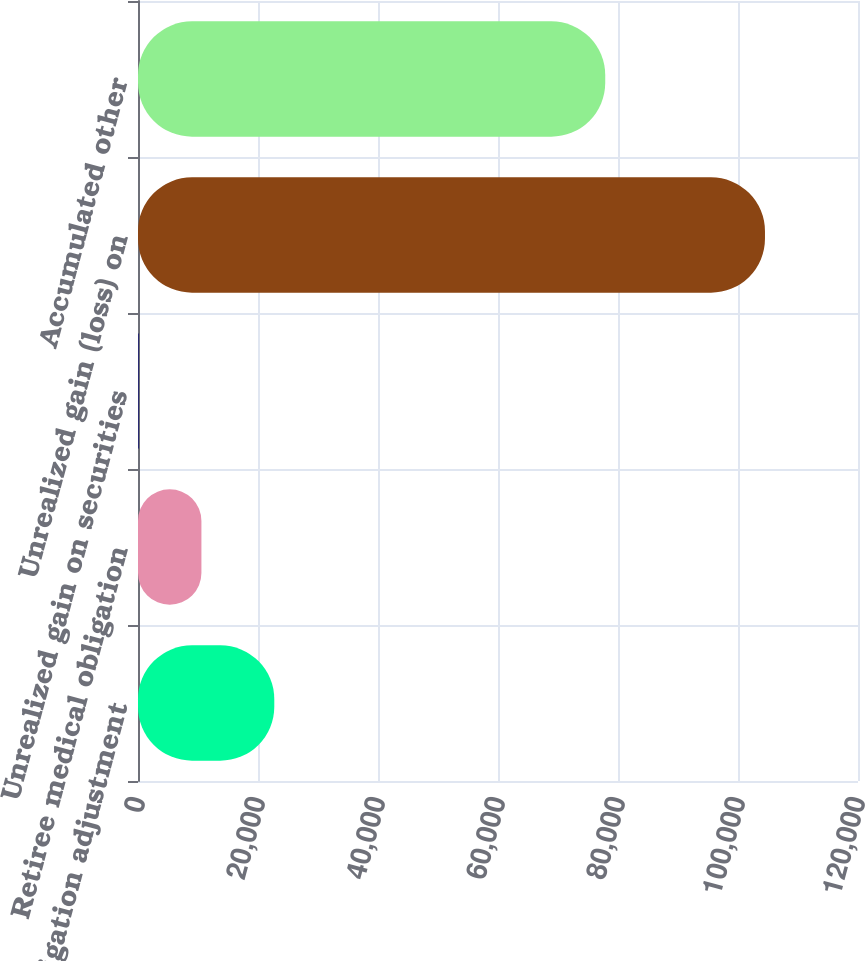Convert chart to OTSL. <chart><loc_0><loc_0><loc_500><loc_500><bar_chart><fcel>Pension obligation adjustment<fcel>Retiree medical obligation<fcel>Unrealized gain on securities<fcel>Unrealized gain (loss) on<fcel>Accumulated other<nl><fcel>22715<fcel>10570.2<fcel>134<fcel>104496<fcel>77873<nl></chart> 